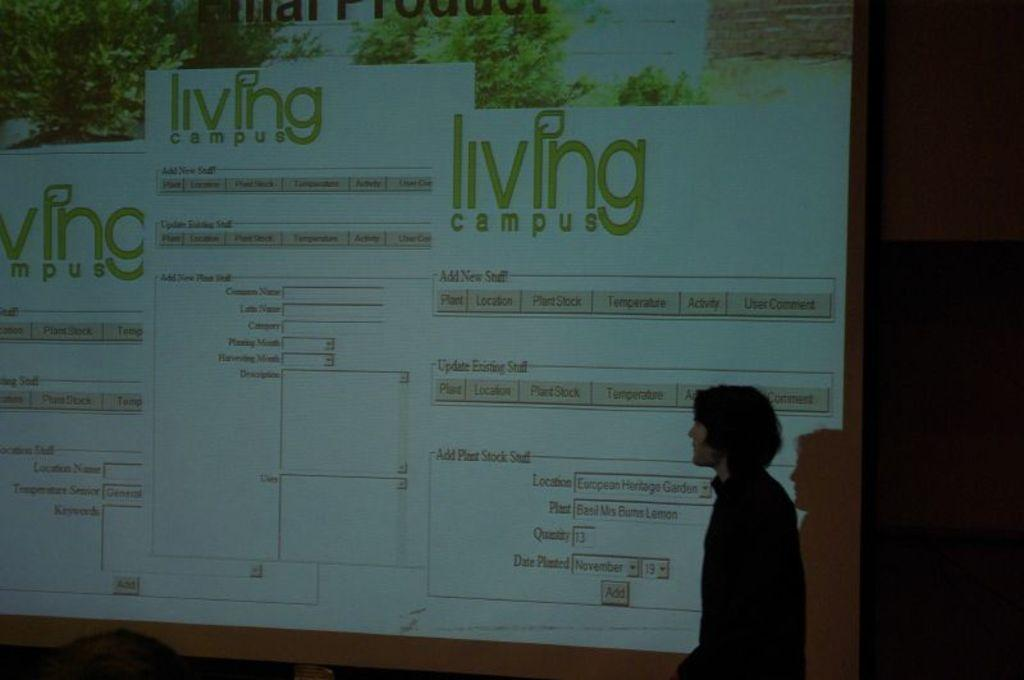<image>
Write a terse but informative summary of the picture. A presentation for living campus is up on the big screen 